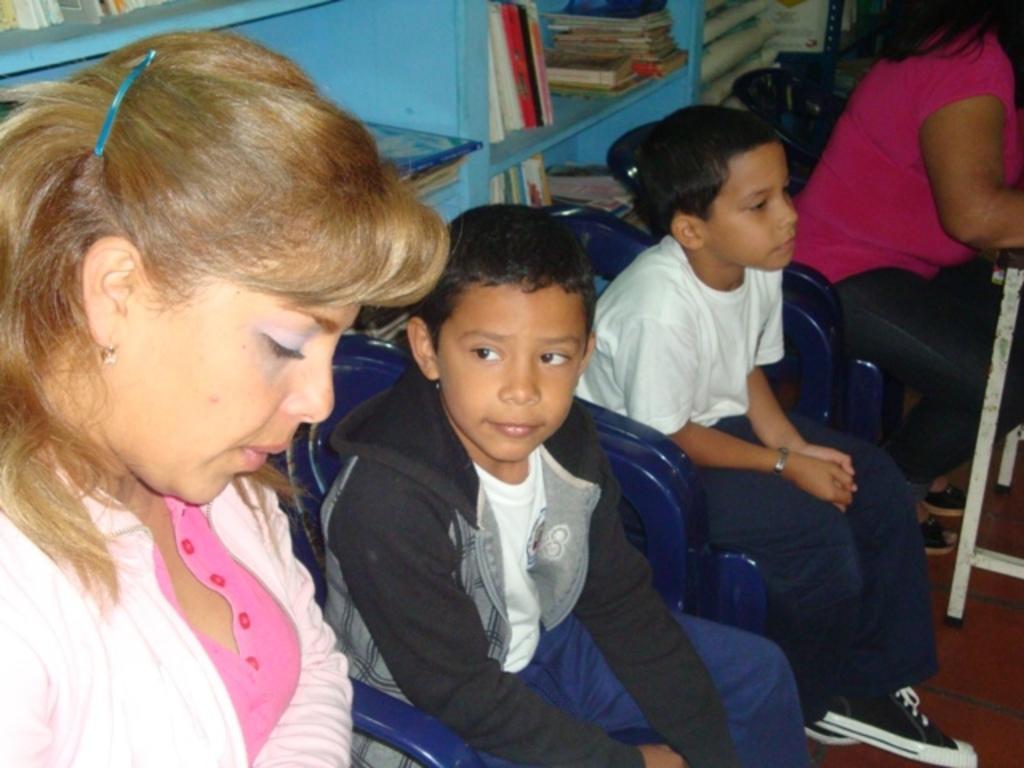Can you describe this image briefly? In this image, I can see four persons sitting on the chairs. In the background, there are books, which are kept in the racks. On the right side of the image, I can see an object on the floor. 